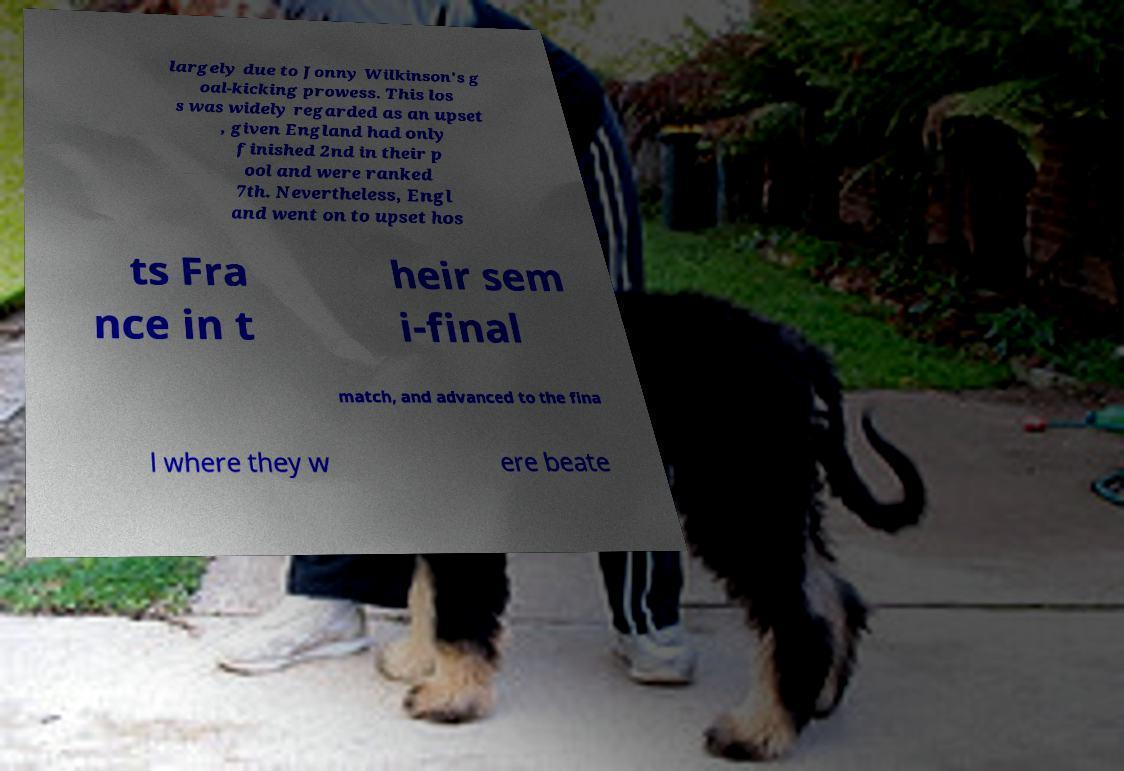Can you read and provide the text displayed in the image?This photo seems to have some interesting text. Can you extract and type it out for me? largely due to Jonny Wilkinson's g oal-kicking prowess. This los s was widely regarded as an upset , given England had only finished 2nd in their p ool and were ranked 7th. Nevertheless, Engl and went on to upset hos ts Fra nce in t heir sem i-final match, and advanced to the fina l where they w ere beate 